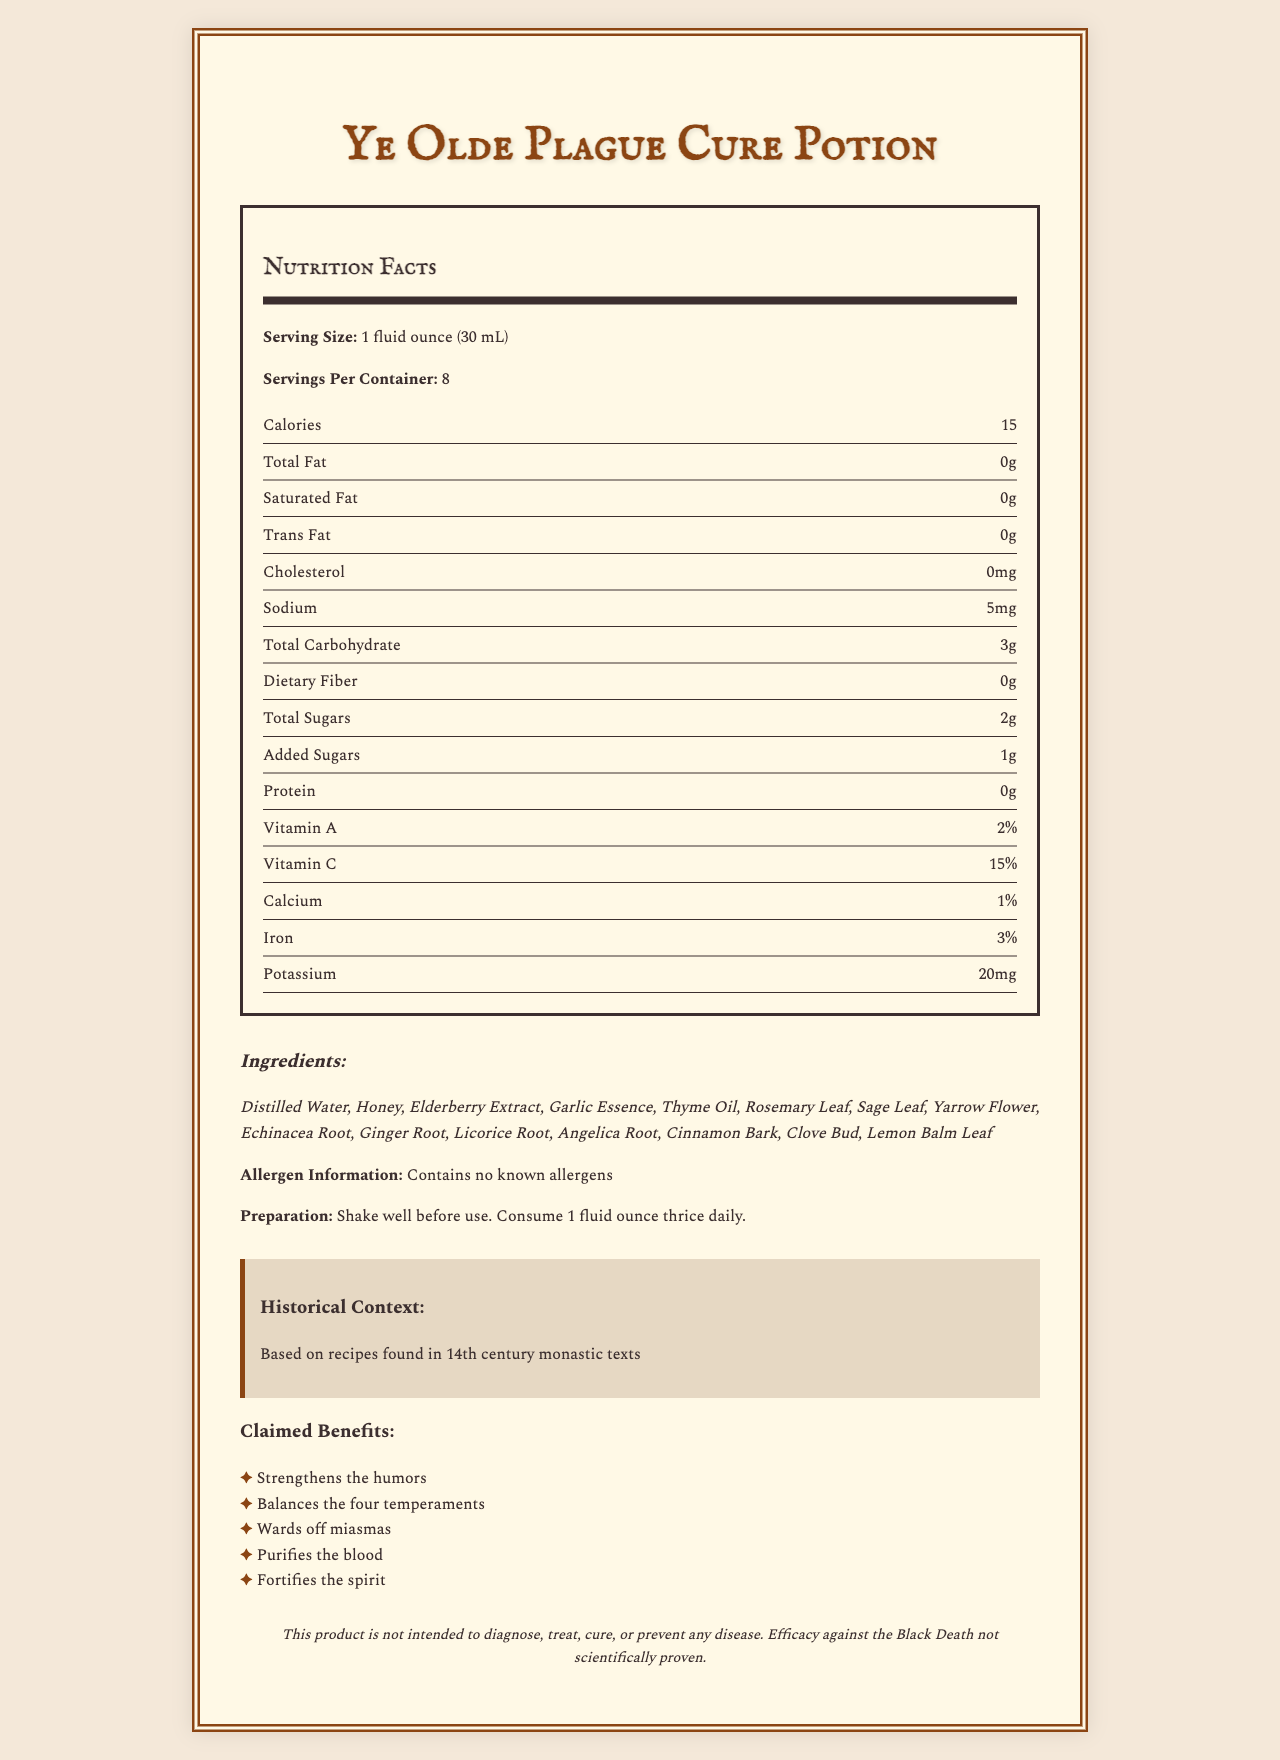What is the serving size of Ye Olde Plague Cure Potion? The serving size is stated clearly in the nutrition label section of the document.
Answer: 1 fluid ounce (30 mL) How many calories are in one serving of the potion? The number of calories per serving is listed as 15 in the nutrition label section.
Answer: 15 What is the sodium content per serving? The sodium content per serving is listed as 5 mg in the nutrition label section.
Answer: 5 mg Name three herbal ingredients in the potion. The ingredients list includes Elderberry Extract, Garlic Essence, and Thyme Oil among others.
Answer: Elderberry Extract, Garlic Essence, Thyme Oil What is the historical basis for this potion? The historical context section mentions recipes from 14th-century monastic texts.
Answer: Recipes found in 14th century monastic texts How many servings are there per container? The servings per container are given as 8 in the nutrition label section.
Answer: 8 What percentage of Vitamin C is in one serving? One serving contains 15% Vitamin C as noted in the nutrition label.
Answer: 15% What is the preparation instruction for the potion? The preparation instruction is clearly stated: "Shake well before use. Consume 1 fluid ounce thrice daily."
Answer: Shake well before use. Consume 1 fluid ounce thrice daily. Does the potion contain any known allergens? The allergen information states that it contains no known allergens.
Answer: No What is the main idea of the document? The main sections cover the product name, serving size, nutrition facts, ingredients, allergen information, preparation, historical context, claimed benefits, and a disclaimer.
Answer: The document provides a detailed description of "Ye Olde Plague Cure Potion," including its nutrition facts, ingredients, historical context, claimed health benefits, and preparation instructions. Which ingredient is likely to give the potion its sweet taste? A. Elderberry Extract B. Honey C. Echinacea Root Honey is commonly known to add sweetness to mixtures, which is supported by its listed presence in the ingredients.
Answer: B The potion is claimed to purify what? A. Blood B. Skin C. Mind The claimed benefits section lists "purifies the blood" as one of the benefits.
Answer: A Based on the document, can the potion cure the Black Death? The disclaimer explicitly states that the product is not intended to diagnose, treat, cure, or prevent any disease, and efficacy against the Black Death is not scientifically proven.
Answer: No What percentage of Iron is provided in one serving? The nutrition label notes that one serving provides 3% Iron.
Answer: 3% Is Cinnamon Bark one of the ingredients in the potion? Cinnamon Bark is listed among the potion's ingredients.
Answer: Yes How can the potion be best described in terms of its intended effects according to claimed benefits? The claimed benefits section outlines these effects in detail.
Answer: The potion is claimed to strengthen the humors, balance the four temperaments, ward off miasmas, purify the blood, and fortify the spirit. What is the concentration of protein per serving? The protein content per serving is stated as 0 grams in the nutrition label.
Answer: 0 g What is the level of added sugars in one serving of the potion? The nutrition label states that there is 1 gram of added sugars per serving.
Answer: 1 g Are there any specific plants associated with medieval European plague treatments mentioned in the ingredients? The document lists ingredients, but does not specify which were historically used in plague treatments.
Answer: Cannot be determined 